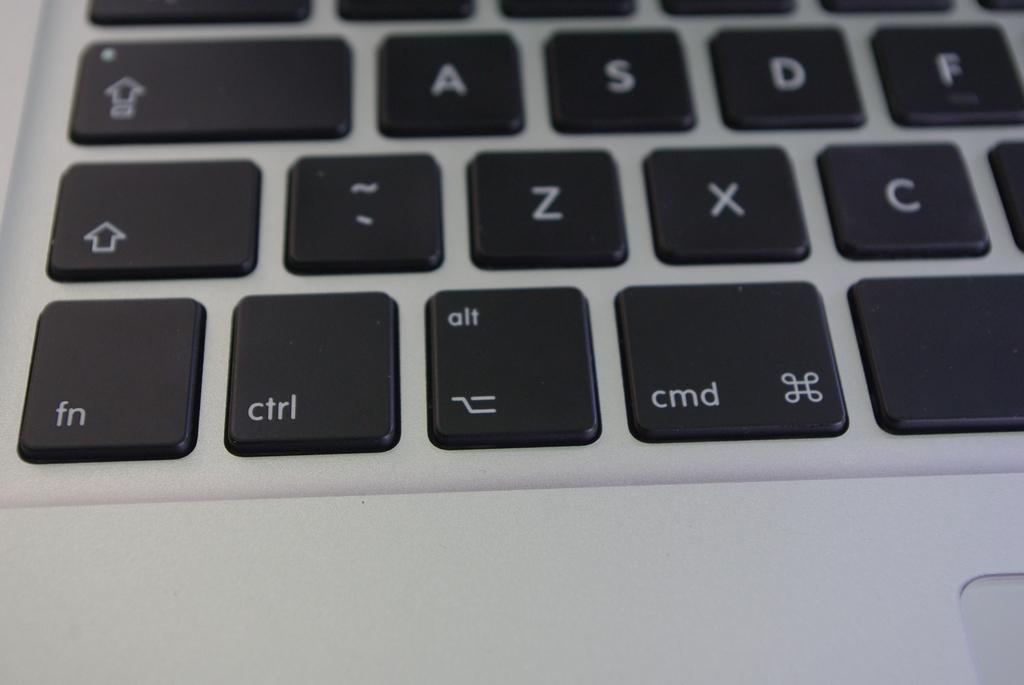What does the button at the bottom left say?
Offer a terse response. Fn. 